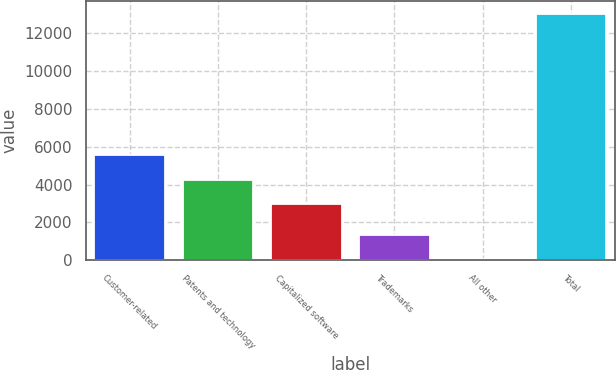<chart> <loc_0><loc_0><loc_500><loc_500><bar_chart><fcel>Customer-related<fcel>Patents and technology<fcel>Capitalized software<fcel>Trademarks<fcel>All other<fcel>Total<nl><fcel>5561.6<fcel>4261.8<fcel>2962<fcel>1353.8<fcel>54<fcel>13052<nl></chart> 